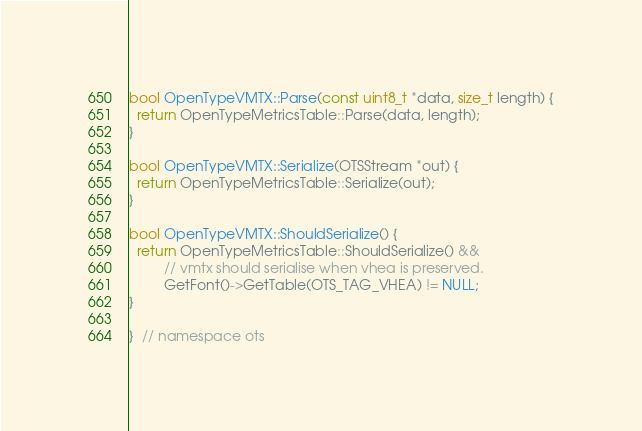<code> <loc_0><loc_0><loc_500><loc_500><_C++_>
bool OpenTypeVMTX::Parse(const uint8_t *data, size_t length) {
  return OpenTypeMetricsTable::Parse(data, length);
}

bool OpenTypeVMTX::Serialize(OTSStream *out) {
  return OpenTypeMetricsTable::Serialize(out);
}

bool OpenTypeVMTX::ShouldSerialize() {
  return OpenTypeMetricsTable::ShouldSerialize() &&
         // vmtx should serialise when vhea is preserved.
         GetFont()->GetTable(OTS_TAG_VHEA) != NULL;
}

}  // namespace ots
</code> 